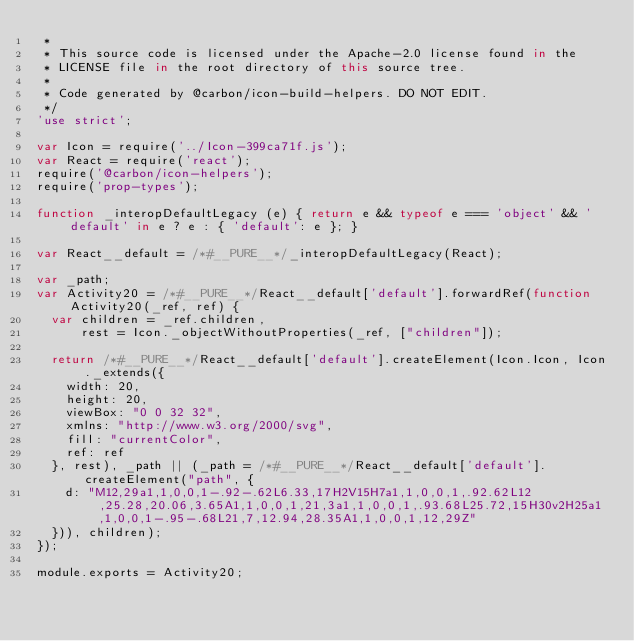<code> <loc_0><loc_0><loc_500><loc_500><_JavaScript_> *
 * This source code is licensed under the Apache-2.0 license found in the
 * LICENSE file in the root directory of this source tree.
 *
 * Code generated by @carbon/icon-build-helpers. DO NOT EDIT.
 */
'use strict';

var Icon = require('../Icon-399ca71f.js');
var React = require('react');
require('@carbon/icon-helpers');
require('prop-types');

function _interopDefaultLegacy (e) { return e && typeof e === 'object' && 'default' in e ? e : { 'default': e }; }

var React__default = /*#__PURE__*/_interopDefaultLegacy(React);

var _path;
var Activity20 = /*#__PURE__*/React__default['default'].forwardRef(function Activity20(_ref, ref) {
  var children = _ref.children,
      rest = Icon._objectWithoutProperties(_ref, ["children"]);

  return /*#__PURE__*/React__default['default'].createElement(Icon.Icon, Icon._extends({
    width: 20,
    height: 20,
    viewBox: "0 0 32 32",
    xmlns: "http://www.w3.org/2000/svg",
    fill: "currentColor",
    ref: ref
  }, rest), _path || (_path = /*#__PURE__*/React__default['default'].createElement("path", {
    d: "M12,29a1,1,0,0,1-.92-.62L6.33,17H2V15H7a1,1,0,0,1,.92.62L12,25.28,20.06,3.65A1,1,0,0,1,21,3a1,1,0,0,1,.93.68L25.72,15H30v2H25a1,1,0,0,1-.95-.68L21,7,12.94,28.35A1,1,0,0,1,12,29Z"
  })), children);
});

module.exports = Activity20;
</code> 